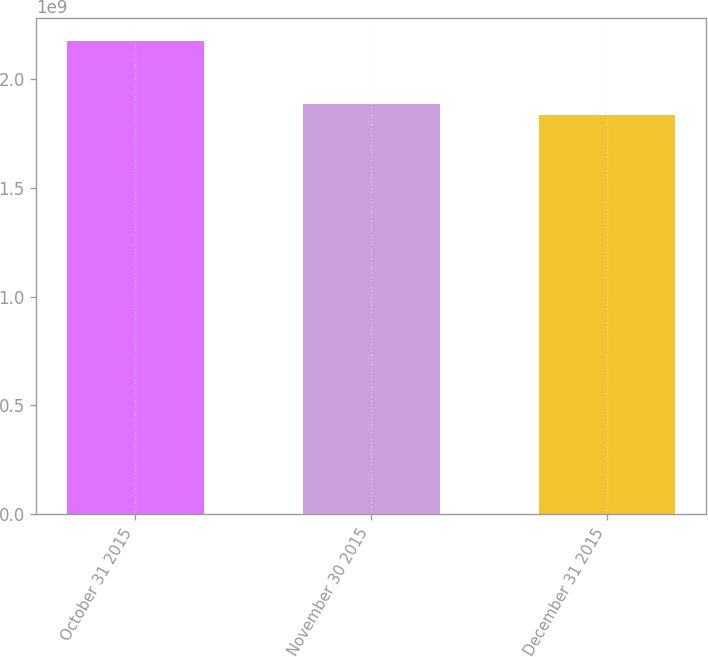Convert chart. <chart><loc_0><loc_0><loc_500><loc_500><bar_chart><fcel>October 31 2015<fcel>November 30 2015<fcel>December 31 2015<nl><fcel>2.17569e+09<fcel>1.88573e+09<fcel>1.83623e+09<nl></chart> 